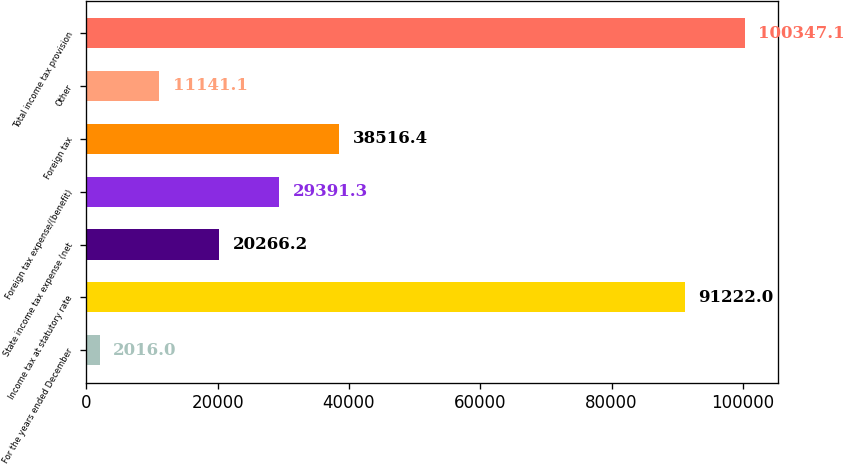Convert chart to OTSL. <chart><loc_0><loc_0><loc_500><loc_500><bar_chart><fcel>For the years ended December<fcel>Income tax at statutory rate<fcel>State income tax expense (net<fcel>Foreign tax expense/(benefit)<fcel>Foreign tax<fcel>Other<fcel>Total income tax provision<nl><fcel>2016<fcel>91222<fcel>20266.2<fcel>29391.3<fcel>38516.4<fcel>11141.1<fcel>100347<nl></chart> 